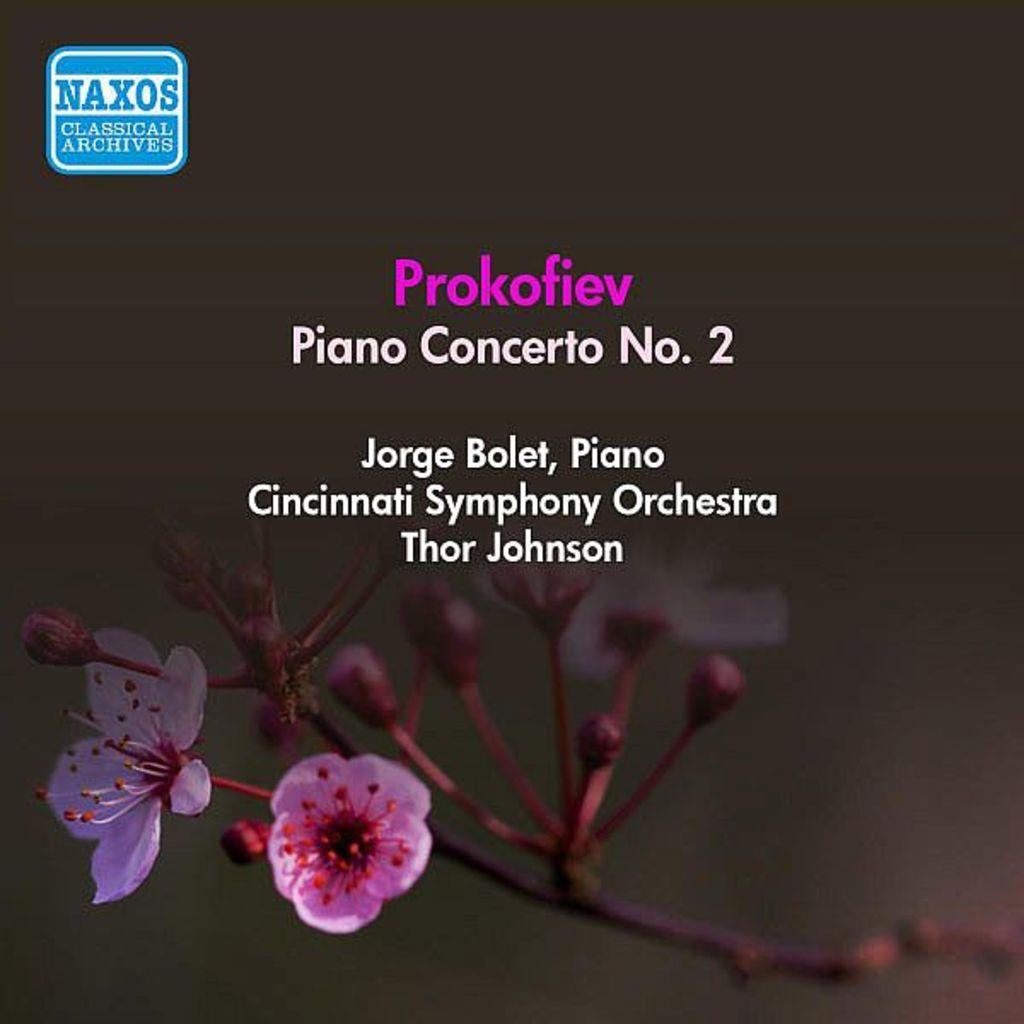What cities orchestra played on this?
Offer a terse response. Cincinnati. What is the name of the orchestra?
Keep it short and to the point. Cincinnati symphony orchestra. 